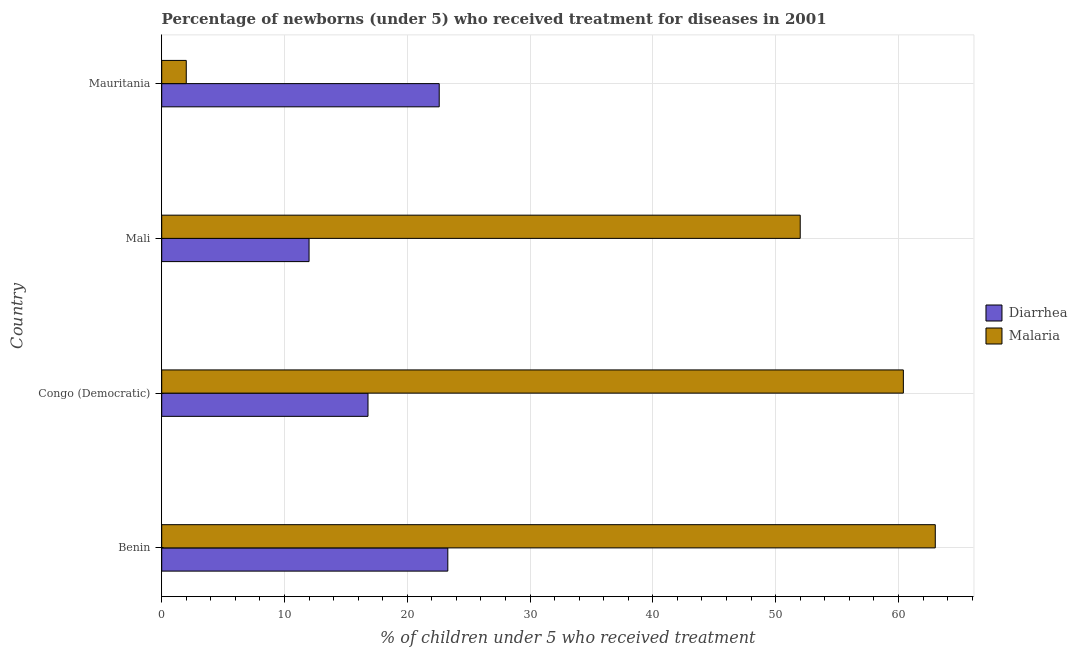Are the number of bars per tick equal to the number of legend labels?
Your answer should be very brief. Yes. Are the number of bars on each tick of the Y-axis equal?
Keep it short and to the point. Yes. What is the label of the 4th group of bars from the top?
Your answer should be compact. Benin. What is the percentage of children who received treatment for diarrhoea in Mauritania?
Keep it short and to the point. 22.6. Across all countries, what is the maximum percentage of children who received treatment for malaria?
Provide a succinct answer. 63. Across all countries, what is the minimum percentage of children who received treatment for diarrhoea?
Provide a short and direct response. 12. In which country was the percentage of children who received treatment for malaria maximum?
Provide a short and direct response. Benin. In which country was the percentage of children who received treatment for malaria minimum?
Make the answer very short. Mauritania. What is the total percentage of children who received treatment for diarrhoea in the graph?
Your answer should be compact. 74.7. What is the difference between the percentage of children who received treatment for malaria in Mali and the percentage of children who received treatment for diarrhoea in Mauritania?
Provide a short and direct response. 29.4. What is the average percentage of children who received treatment for diarrhoea per country?
Offer a very short reply. 18.68. What is the ratio of the percentage of children who received treatment for diarrhoea in Mali to that in Mauritania?
Your answer should be compact. 0.53. Is the sum of the percentage of children who received treatment for malaria in Mali and Mauritania greater than the maximum percentage of children who received treatment for diarrhoea across all countries?
Make the answer very short. Yes. What does the 1st bar from the top in Benin represents?
Keep it short and to the point. Malaria. What does the 2nd bar from the bottom in Benin represents?
Provide a short and direct response. Malaria. How many bars are there?
Provide a succinct answer. 8. Where does the legend appear in the graph?
Provide a short and direct response. Center right. How are the legend labels stacked?
Provide a succinct answer. Vertical. What is the title of the graph?
Make the answer very short. Percentage of newborns (under 5) who received treatment for diseases in 2001. What is the label or title of the X-axis?
Offer a very short reply. % of children under 5 who received treatment. What is the label or title of the Y-axis?
Offer a very short reply. Country. What is the % of children under 5 who received treatment in Diarrhea in Benin?
Offer a terse response. 23.3. What is the % of children under 5 who received treatment of Malaria in Benin?
Provide a succinct answer. 63. What is the % of children under 5 who received treatment of Malaria in Congo (Democratic)?
Keep it short and to the point. 60.4. What is the % of children under 5 who received treatment of Diarrhea in Mali?
Ensure brevity in your answer.  12. What is the % of children under 5 who received treatment in Malaria in Mali?
Give a very brief answer. 52. What is the % of children under 5 who received treatment in Diarrhea in Mauritania?
Offer a very short reply. 22.6. What is the % of children under 5 who received treatment of Malaria in Mauritania?
Keep it short and to the point. 2. Across all countries, what is the maximum % of children under 5 who received treatment of Diarrhea?
Your answer should be compact. 23.3. Across all countries, what is the maximum % of children under 5 who received treatment in Malaria?
Offer a terse response. 63. Across all countries, what is the minimum % of children under 5 who received treatment of Diarrhea?
Make the answer very short. 12. Across all countries, what is the minimum % of children under 5 who received treatment in Malaria?
Your answer should be compact. 2. What is the total % of children under 5 who received treatment in Diarrhea in the graph?
Your response must be concise. 74.7. What is the total % of children under 5 who received treatment of Malaria in the graph?
Provide a short and direct response. 177.4. What is the difference between the % of children under 5 who received treatment in Malaria in Benin and that in Congo (Democratic)?
Provide a succinct answer. 2.6. What is the difference between the % of children under 5 who received treatment of Malaria in Benin and that in Mali?
Keep it short and to the point. 11. What is the difference between the % of children under 5 who received treatment of Diarrhea in Benin and that in Mauritania?
Offer a very short reply. 0.7. What is the difference between the % of children under 5 who received treatment in Diarrhea in Congo (Democratic) and that in Mali?
Ensure brevity in your answer.  4.8. What is the difference between the % of children under 5 who received treatment of Malaria in Congo (Democratic) and that in Mauritania?
Make the answer very short. 58.4. What is the difference between the % of children under 5 who received treatment of Diarrhea in Benin and the % of children under 5 who received treatment of Malaria in Congo (Democratic)?
Offer a very short reply. -37.1. What is the difference between the % of children under 5 who received treatment of Diarrhea in Benin and the % of children under 5 who received treatment of Malaria in Mali?
Provide a succinct answer. -28.7. What is the difference between the % of children under 5 who received treatment of Diarrhea in Benin and the % of children under 5 who received treatment of Malaria in Mauritania?
Ensure brevity in your answer.  21.3. What is the difference between the % of children under 5 who received treatment of Diarrhea in Congo (Democratic) and the % of children under 5 who received treatment of Malaria in Mali?
Provide a short and direct response. -35.2. What is the difference between the % of children under 5 who received treatment of Diarrhea in Mali and the % of children under 5 who received treatment of Malaria in Mauritania?
Keep it short and to the point. 10. What is the average % of children under 5 who received treatment of Diarrhea per country?
Provide a short and direct response. 18.68. What is the average % of children under 5 who received treatment of Malaria per country?
Your answer should be very brief. 44.35. What is the difference between the % of children under 5 who received treatment in Diarrhea and % of children under 5 who received treatment in Malaria in Benin?
Keep it short and to the point. -39.7. What is the difference between the % of children under 5 who received treatment of Diarrhea and % of children under 5 who received treatment of Malaria in Congo (Democratic)?
Offer a terse response. -43.6. What is the difference between the % of children under 5 who received treatment in Diarrhea and % of children under 5 who received treatment in Malaria in Mauritania?
Give a very brief answer. 20.6. What is the ratio of the % of children under 5 who received treatment of Diarrhea in Benin to that in Congo (Democratic)?
Provide a short and direct response. 1.39. What is the ratio of the % of children under 5 who received treatment in Malaria in Benin to that in Congo (Democratic)?
Ensure brevity in your answer.  1.04. What is the ratio of the % of children under 5 who received treatment of Diarrhea in Benin to that in Mali?
Give a very brief answer. 1.94. What is the ratio of the % of children under 5 who received treatment of Malaria in Benin to that in Mali?
Your answer should be very brief. 1.21. What is the ratio of the % of children under 5 who received treatment of Diarrhea in Benin to that in Mauritania?
Ensure brevity in your answer.  1.03. What is the ratio of the % of children under 5 who received treatment in Malaria in Benin to that in Mauritania?
Provide a short and direct response. 31.5. What is the ratio of the % of children under 5 who received treatment in Malaria in Congo (Democratic) to that in Mali?
Offer a very short reply. 1.16. What is the ratio of the % of children under 5 who received treatment in Diarrhea in Congo (Democratic) to that in Mauritania?
Your answer should be very brief. 0.74. What is the ratio of the % of children under 5 who received treatment in Malaria in Congo (Democratic) to that in Mauritania?
Give a very brief answer. 30.2. What is the ratio of the % of children under 5 who received treatment in Diarrhea in Mali to that in Mauritania?
Give a very brief answer. 0.53. What is the ratio of the % of children under 5 who received treatment of Malaria in Mali to that in Mauritania?
Offer a very short reply. 26. What is the difference between the highest and the second highest % of children under 5 who received treatment in Malaria?
Offer a very short reply. 2.6. What is the difference between the highest and the lowest % of children under 5 who received treatment in Diarrhea?
Offer a very short reply. 11.3. What is the difference between the highest and the lowest % of children under 5 who received treatment of Malaria?
Give a very brief answer. 61. 